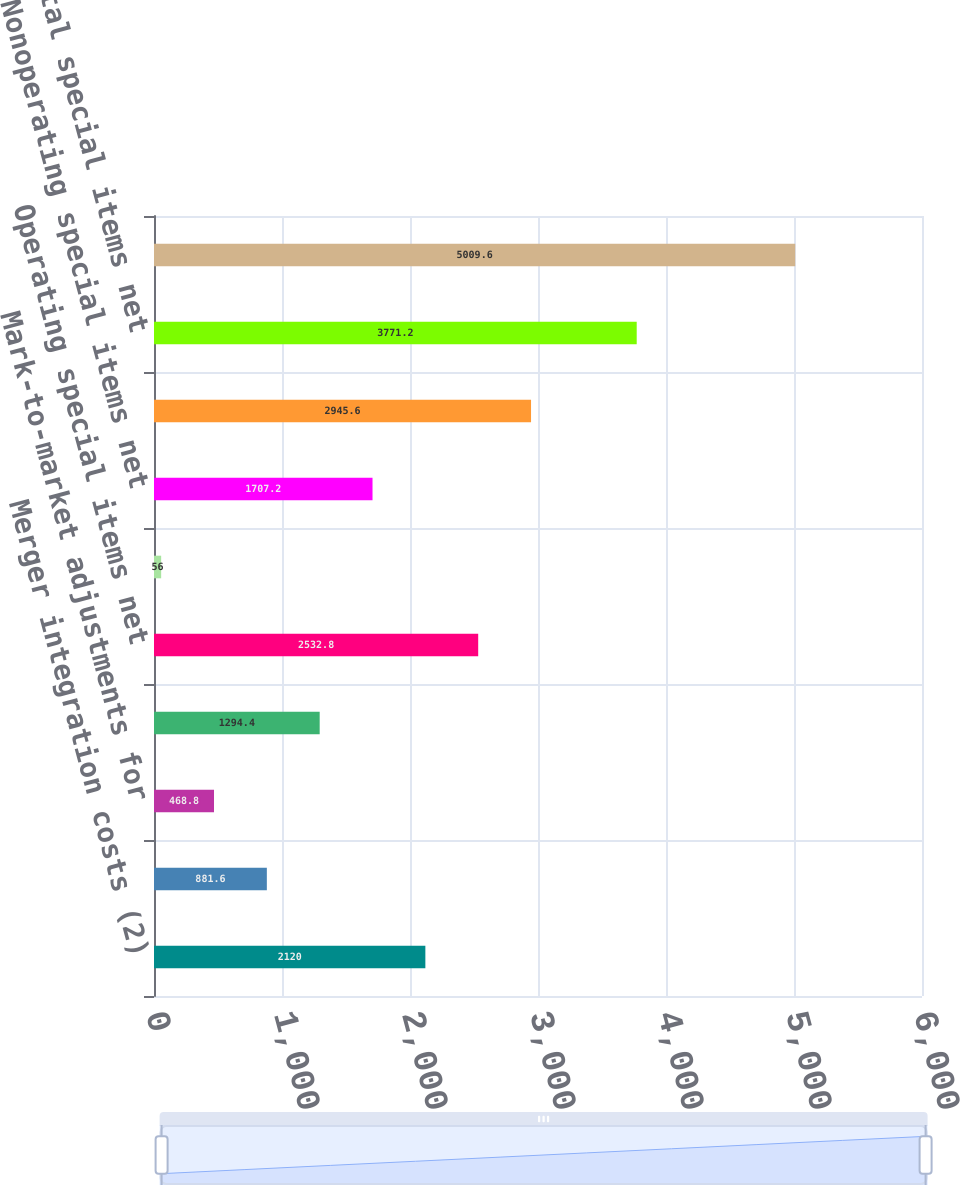<chart> <loc_0><loc_0><loc_500><loc_500><bar_chart><fcel>Merger integration costs (2)<fcel>Fleet restructuring costs (3)<fcel>Mark-to-market adjustments for<fcel>Other operating charges<fcel>Operating special items net<fcel>Debt extinguishment and<fcel>Nonoperating special items net<fcel>Pre-tax special items net<fcel>Total special items net<fcel>Pre-tax income - GAAP<nl><fcel>2120<fcel>881.6<fcel>468.8<fcel>1294.4<fcel>2532.8<fcel>56<fcel>1707.2<fcel>2945.6<fcel>3771.2<fcel>5009.6<nl></chart> 